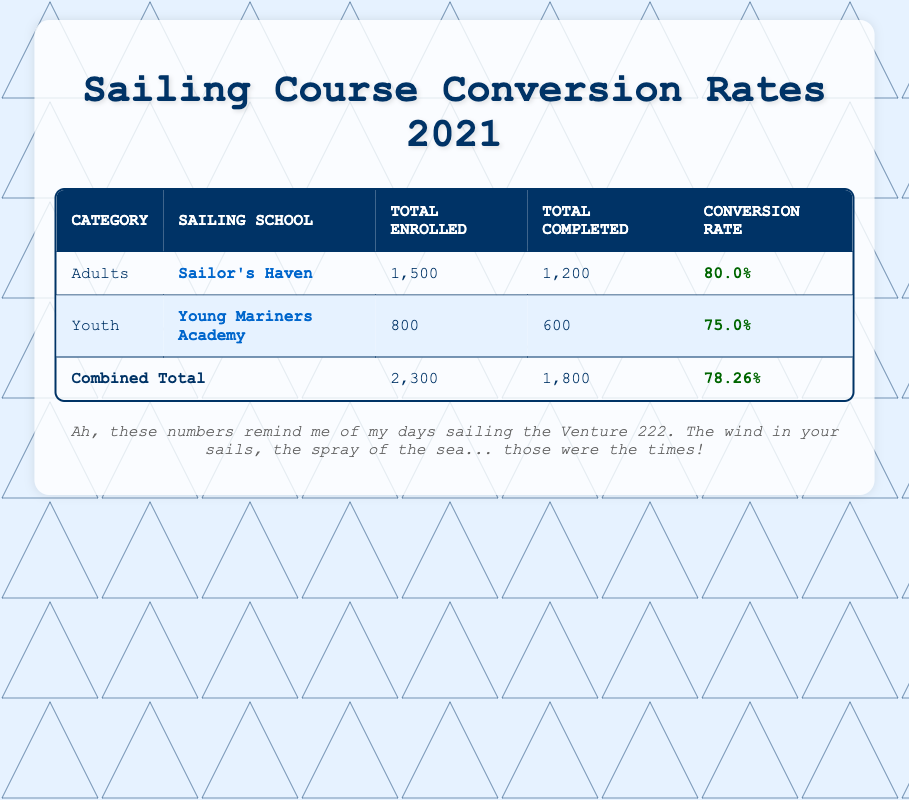What is the conversion rate for adults in 2021? The table shows the conversion rate for adults listed under the "Adults" category specifically as 80.0%.
Answer: 80.0% How many total courses were completed by youth in 2021? In the table, the number of total completed courses for youth is provided as 600 under the "Total Completed" column.
Answer: 600 What is the overall conversion rate for all courses combined in 2021? The overall conversion rate for all courses combined is directly stated as 78.26% in the "overallConversionRate" row of the table.
Answer: 78.26% Which sailing school had a higher conversion rate, adults or youth? The conversion rate for adults from Sailor's Haven is 80.0%, while for youth from Young Mariners Academy, it is 75.0%. Since 80.0% is greater than 75.0%, adults had a higher conversion rate.
Answer: Adults What was the difference in total enrolled between adults and youth? The table shows that adults had 1,500 total enrolled and youth had 800 total enrolled. The difference is calculated by subtracting the youth total from the adults total: 1,500 - 800 = 700.
Answer: 700 Did more youth or adults complete their courses in 2021? In the table, adults completed 1,200 courses and youth completed 600 courses. Since 1,200 is greater than 600, more adults completed their courses than youth.
Answer: Yes What percentage of youth enrolled compared to the combined total? The total enrolled for youth is 800, while the combined total enrolled is 2,300. To find the percentage: (800 / 2,300) * 100 = approximately 34.78%. Therefore, youth comprised about 34.78% of the total enrollments.
Answer: 34.78% How many total courses were completed by adults and youth combined? By adding the total completed courses for adults (1,200) and youth (600), we find the total completed combined: 1,200 + 600 = 1,800.
Answer: 1,800 Was the completion rate for adults higher than that for youth? The completion rate for adults is 80.0%, while the completion rate for youth is 75.0%. Since 80.0% is higher than 75.0%, the completion rate for adults was indeed higher.
Answer: Yes 